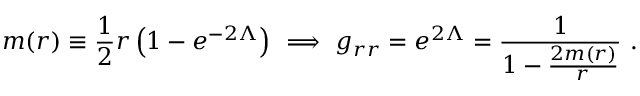<formula> <loc_0><loc_0><loc_500><loc_500>m ( r ) \equiv \frac { 1 } { 2 } r \left ( 1 - e ^ { - 2 \Lambda } \right ) \ \Longrightarrow \ g _ { r r } = e ^ { 2 \Lambda } = \frac { 1 } { 1 - \frac { 2 m ( r ) } { r } } \ .</formula> 